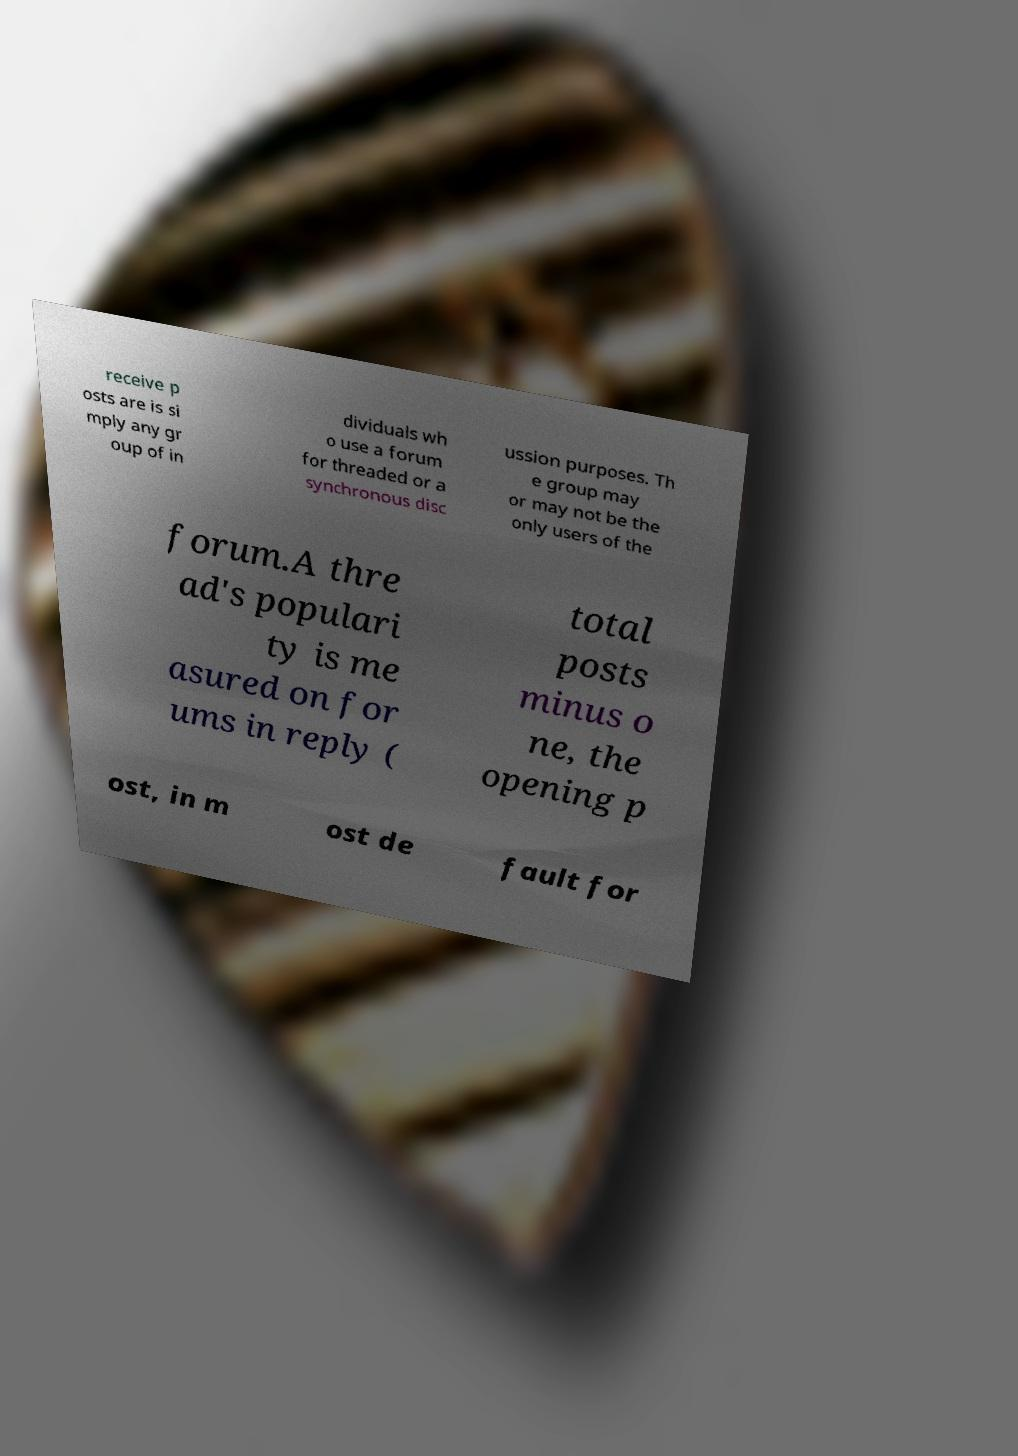I need the written content from this picture converted into text. Can you do that? receive p osts are is si mply any gr oup of in dividuals wh o use a forum for threaded or a synchronous disc ussion purposes. Th e group may or may not be the only users of the forum.A thre ad's populari ty is me asured on for ums in reply ( total posts minus o ne, the opening p ost, in m ost de fault for 